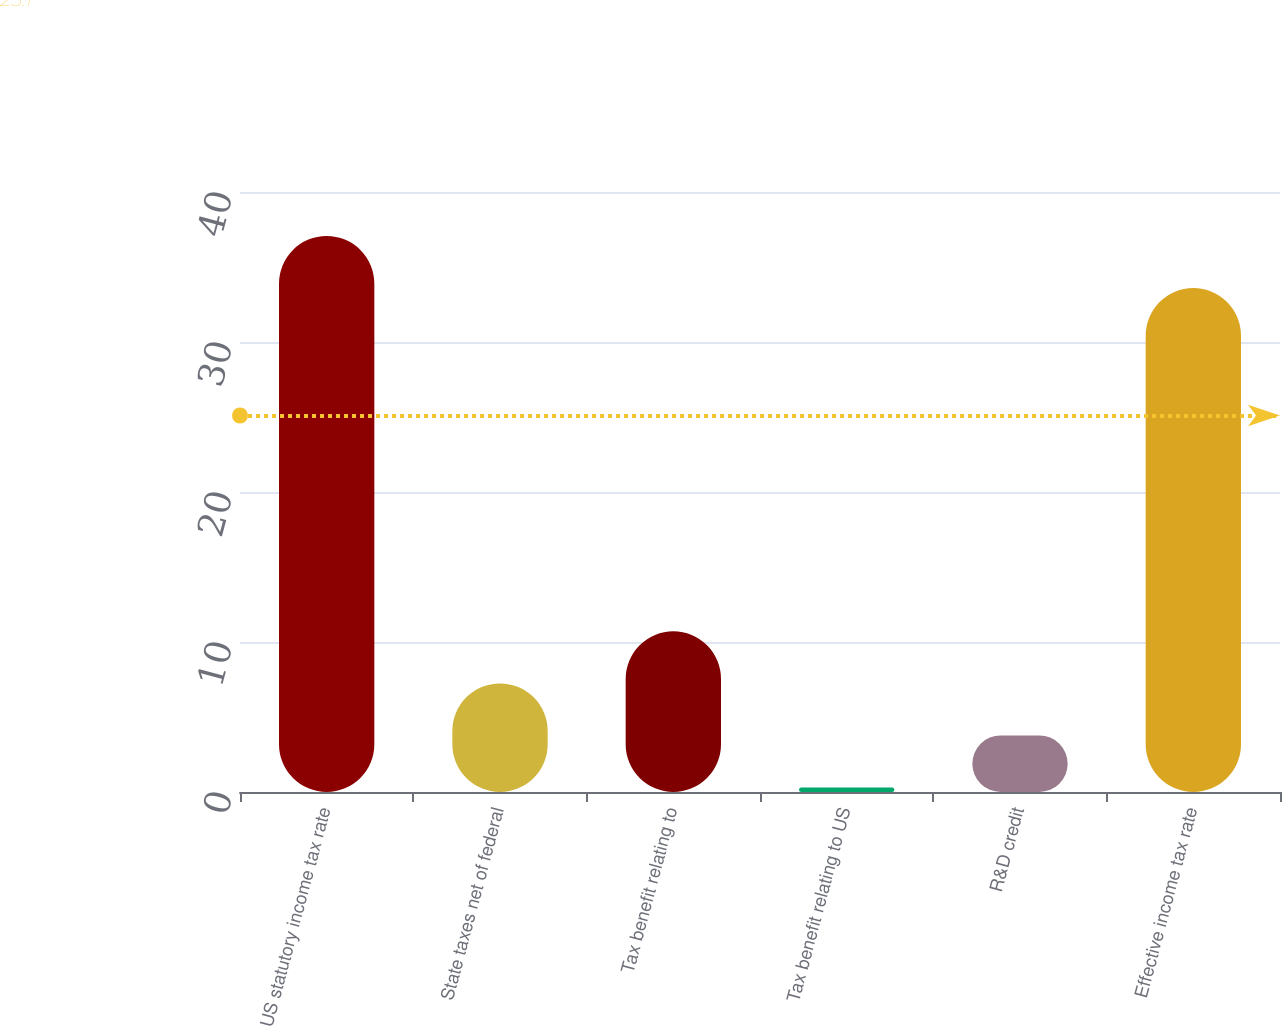Convert chart. <chart><loc_0><loc_0><loc_500><loc_500><bar_chart><fcel>US statutory income tax rate<fcel>State taxes net of federal<fcel>Tax benefit relating to<fcel>Tax benefit relating to US<fcel>R&D credit<fcel>Effective income tax rate<nl><fcel>37.07<fcel>7.24<fcel>10.71<fcel>0.3<fcel>3.77<fcel>33.6<nl></chart> 